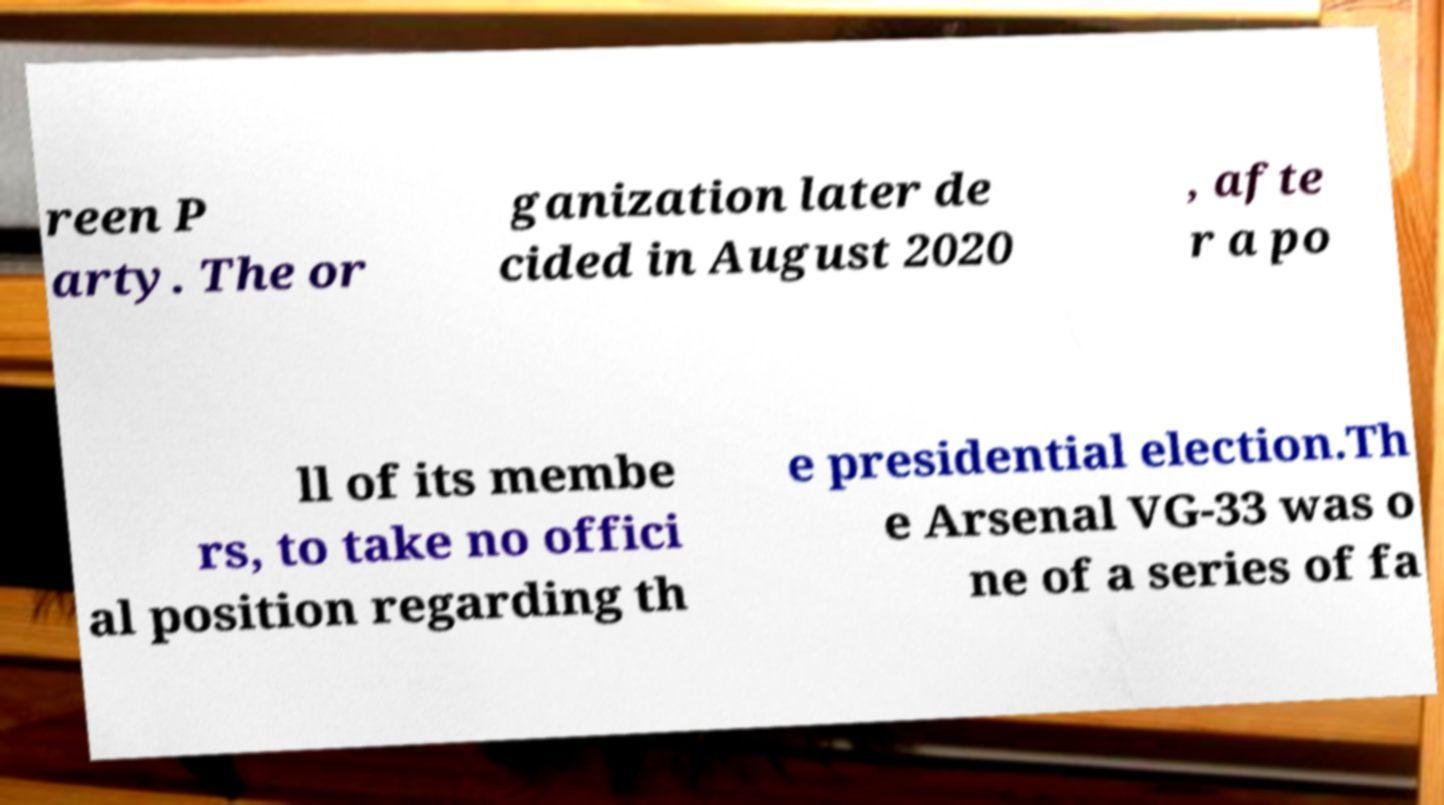What messages or text are displayed in this image? I need them in a readable, typed format. reen P arty. The or ganization later de cided in August 2020 , afte r a po ll of its membe rs, to take no offici al position regarding th e presidential election.Th e Arsenal VG-33 was o ne of a series of fa 